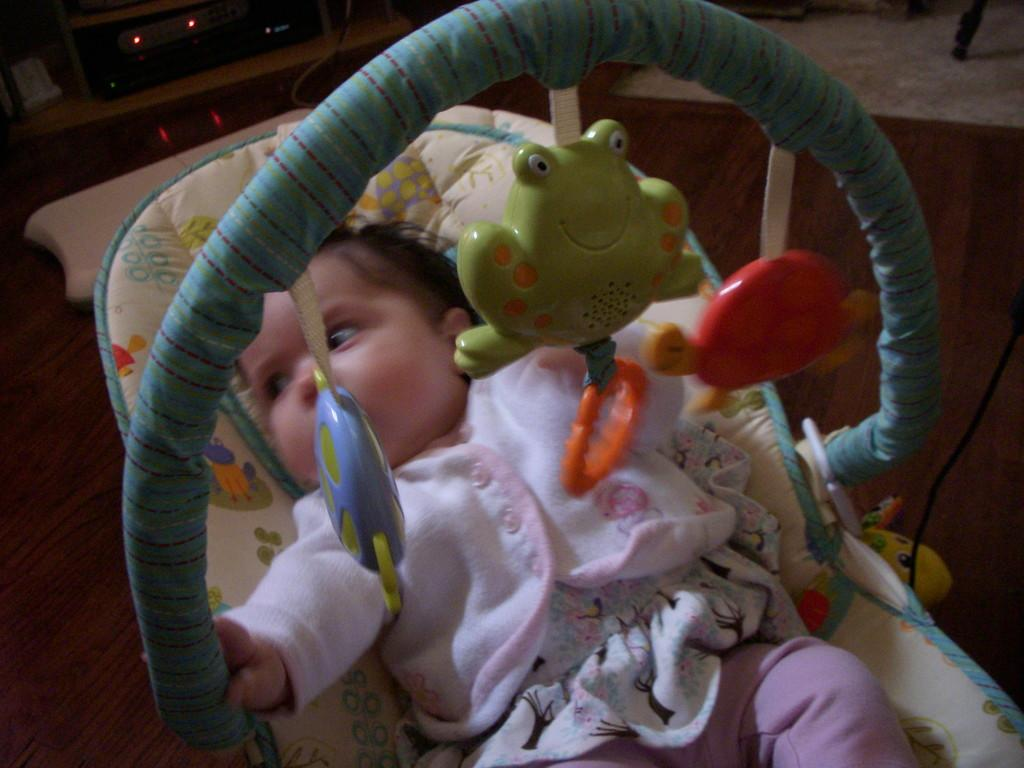What is the main object in the image? There is a baby cot in the image. What is happening inside the baby cot? A baby is lying in the baby cot. What can be seen above the baby cot? There are toys above the baby cot. How many bikes are parked next to the baby cot in the image? There are no bikes present in the image. Is the baby carrying a bag in the image? There is no bag visible in the image, as the baby is lying in the baby cot. 